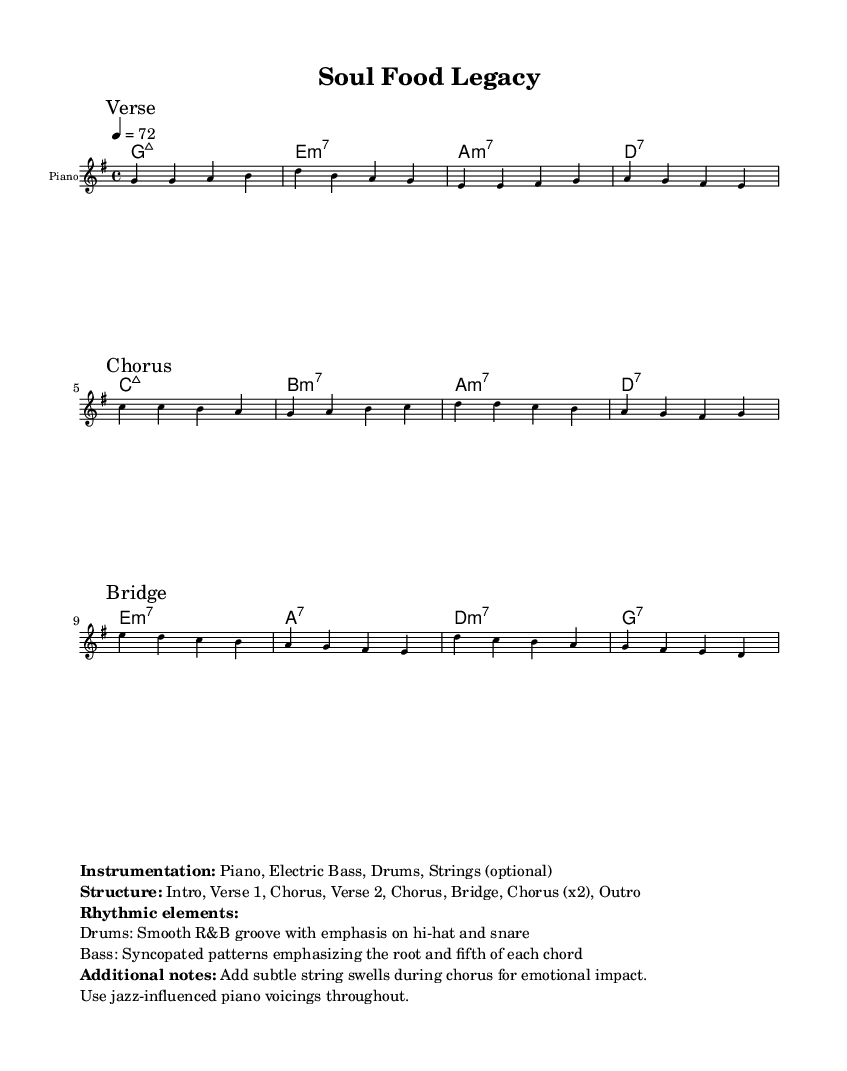What is the key signature of this music? The key signature is G major, which has one sharp (F#). This can be identified by looking at the key signature indicated at the beginning of the staff where there is a single sharp on the top line (F).
Answer: G major What is the time signature of this music? The time signature is 4/4, which means there are four beats in each measure. This is clearly indicated at the beginning of the score where the time signature is listed, showing the fraction 4 over 4.
Answer: 4/4 What is the tempo marking for this piece? The tempo is marked as 4 = 72, indicating that the quarter note should be played at a speed of 72 beats per minute. This is also found at the beginning of the sheet music next to the tempo marking.
Answer: 72 What instruments are included in the instrumentation? The indicated instruments are Piano, Electric Bass, Drums, and optional Strings. This information is specified in the markup section, detailing what instruments are part of the arrangement.
Answer: Piano, Electric Bass, Drums, Strings How many sections are in the structure of this piece? The structure consists of 7 sections: Intro, Verse 1, Chorus, Verse 2, Chorus, Bridge, Chorus (x2), and Outro. This can be seen in the markup section which lists the overall structure in clear terms.
Answer: 7 What rhythmic elements are specified for the drums? The rhythmic element specified for the drums is a Smooth R&B groove with emphasis on hi-hat and snare. This detail can be found in the markup section which elaborates on the rhythmic characteristics of the piece.
Answer: Smooth R&B groove What kind of jazz influence is noted in the piano voicings? The additional note mentions using jazz-influenced piano voicings throughout the piece. This detail is highlighted in the markup section, suggesting a stylistic choice for the piano part.
Answer: Jazz-influenced 